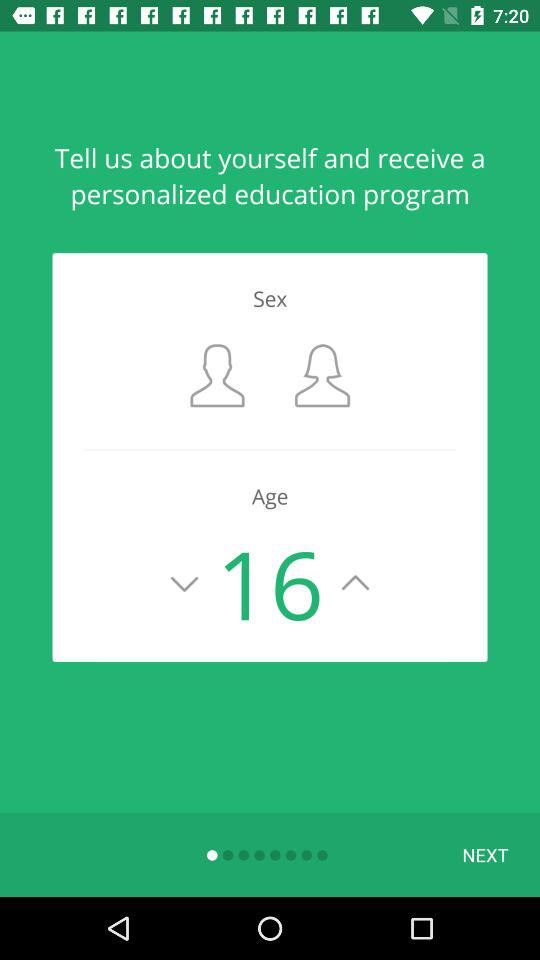What is the selected age? The selected age is 16. 